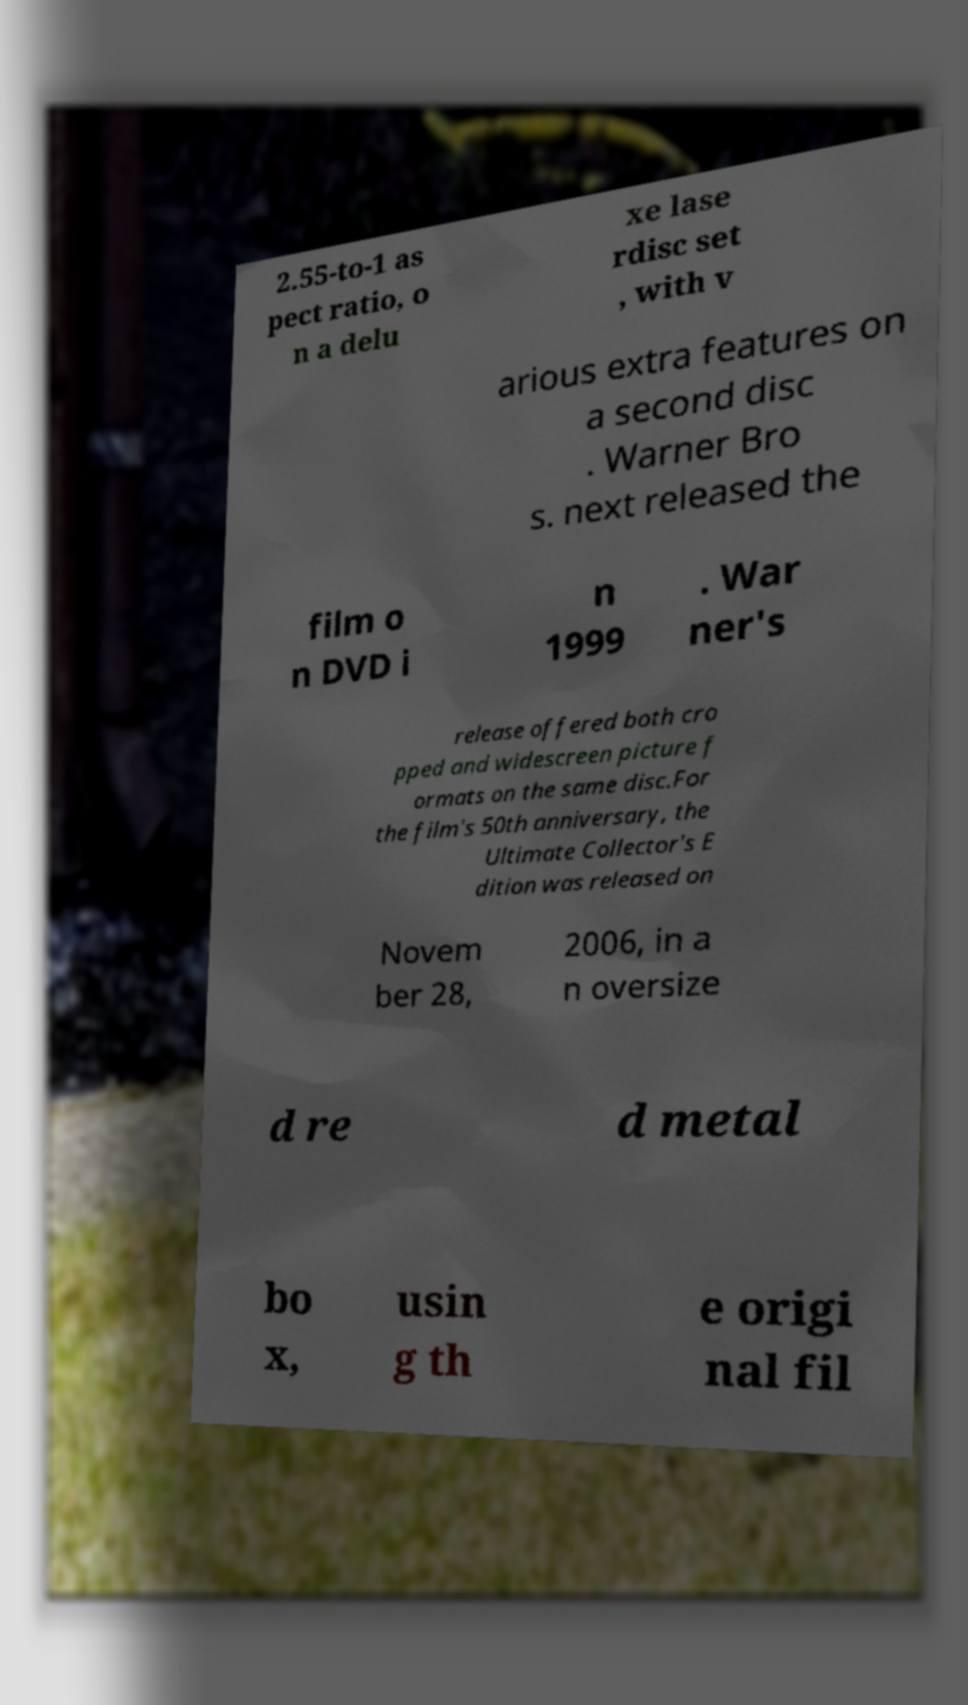Please read and relay the text visible in this image. What does it say? 2.55-to-1 as pect ratio, o n a delu xe lase rdisc set , with v arious extra features on a second disc . Warner Bro s. next released the film o n DVD i n 1999 . War ner's release offered both cro pped and widescreen picture f ormats on the same disc.For the film's 50th anniversary, the Ultimate Collector's E dition was released on Novem ber 28, 2006, in a n oversize d re d metal bo x, usin g th e origi nal fil 